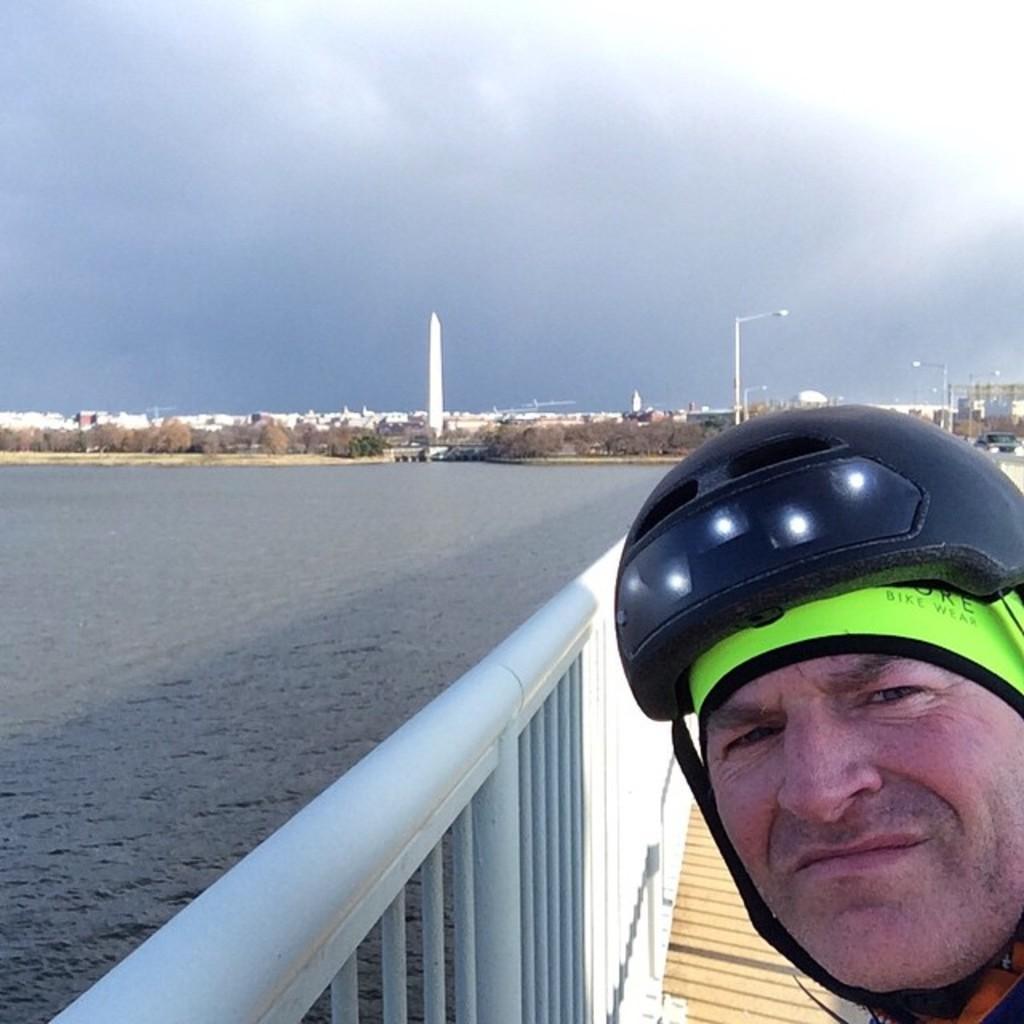How would you summarize this image in a sentence or two? On the right we can see a person wearing a helmet. There is a railing. On the left we can see water. In the background there are trees, buildings, towers, poles and sky. 